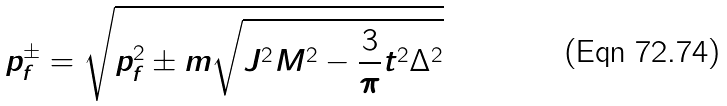<formula> <loc_0><loc_0><loc_500><loc_500>p ^ { \pm } _ { f } = \sqrt { p ^ { 2 } _ { f } \pm m \sqrt { J ^ { 2 } M ^ { 2 } - \frac { 3 } { \pi } t ^ { 2 } \Delta ^ { 2 } } }</formula> 